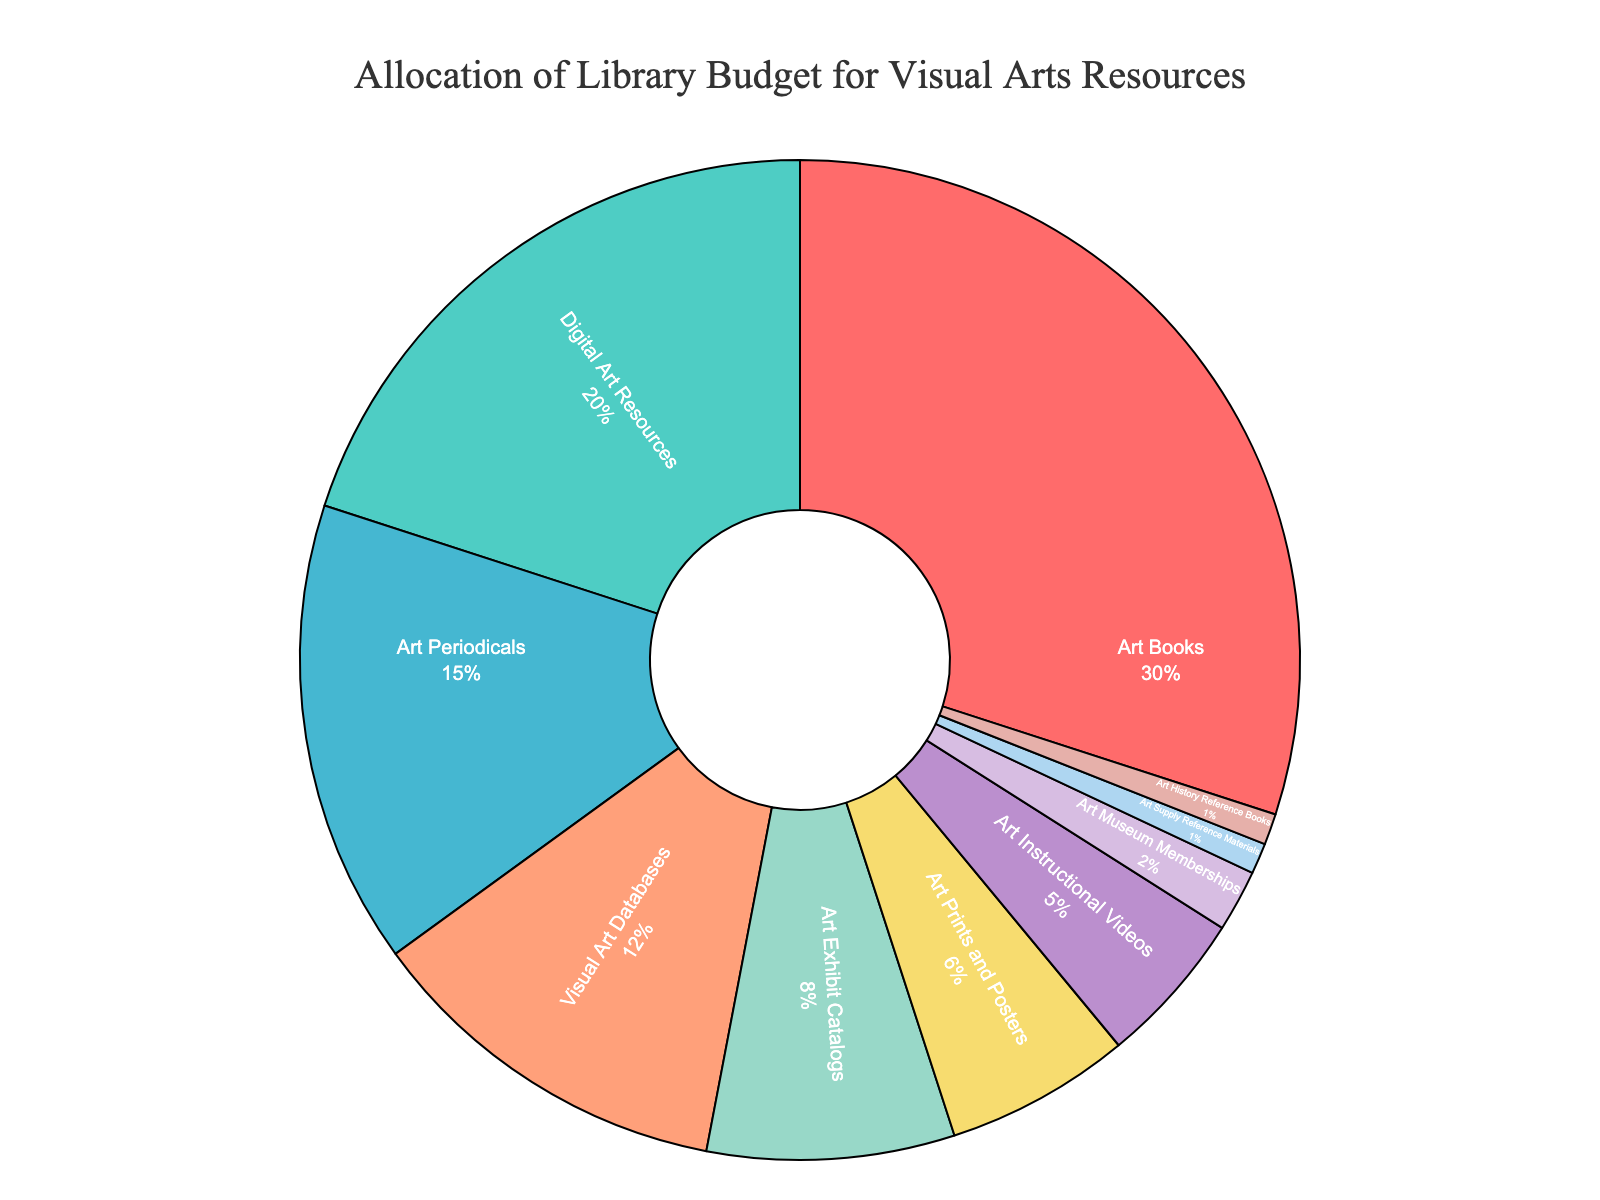What percentage of the budget is allocated to Digital Art Resources? The category 'Digital Art Resources' is labeled as having 20% of the budget in the pie chart.
Answer: 20% Which two categories have the smallest budget allocation? By examining the pie chart, 'Art Supply Reference Materials' and 'Art History Reference Books' have the smallest slices, each labeled as 1%.
Answer: Art Supply Reference Materials, Art History Reference Books How much of the budget is allocated to categories other than Art Books? The slice representing 'Art Books' is labeled as 30%, so the percentage for other categories is calculated as 100% - 30% = 70%.
Answer: 70% Are there more resources allocated to Visual Art Databases or to Art Periodicals? By comparing the slices, 'Art Periodicals' shows 15% while 'Visual Art Databases' shows 12%. 15% is greater than 12%.
Answer: Art Periodicals Which category has the second-largest allocation, and what is its percentage? After 'Art Books', which has 30%, 'Digital Art Resources' is the next largest with 20%.
Answer: Digital Art Resources, 20% How many categories have a budget allocation greater than or equal to 10%? The categories 'Art Books' (30%), 'Digital Art Resources' (20%), 'Art Periodicals' (15%), and 'Visual Art Databases' (12%) are each 10% or higher.
Answer: Four What is the combined allocation percentage for Art Prints and Posters and Art Exhibit Catalogs? 'Art Prints and Posters' is at 6%, and 'Art Exhibit Catalogs' is at 8%. The sum is 6% + 8% = 14%.
Answer: 14% Is the budget allocation for Art Instructional Videos greater than that for Art Prints and Posters? 'Art Instructional Videos' shows 5% while 'Art Prints and Posters' shows 6%. 5% is less than 6%.
Answer: No What is the total percentage allocated to Art Instructional Videos, Art Museum Memberships, and Art Supply Reference Materials combined? Adding 'Art Instructional Videos' (5%), 'Art Museum Memberships' (2%), and 'Art Supply Reference Materials' (1%) gives a total of 5% + 2% + 1% = 8%.
Answer: 8% Which two categories together constitute exactly one-third of the budget allocation? 'Art Books' (30%) together with 'Art Periodicals' (15%) have a sum of 30% + 15% = 45%, which is not a third of the total 100%. Combining 'Art Books' (30%) with 'Digital Art Resources' (20%) results in 30% + 20% = 50%, which is not the correct pairs either. However, combining 'Digital Art Resources' (20%) and 'Art Periodicals' (15%) gives 20% + 15% = 35%, which does not fit. Upon further inspection, no two categories exactly sum to 33.33%.
Answer: None 